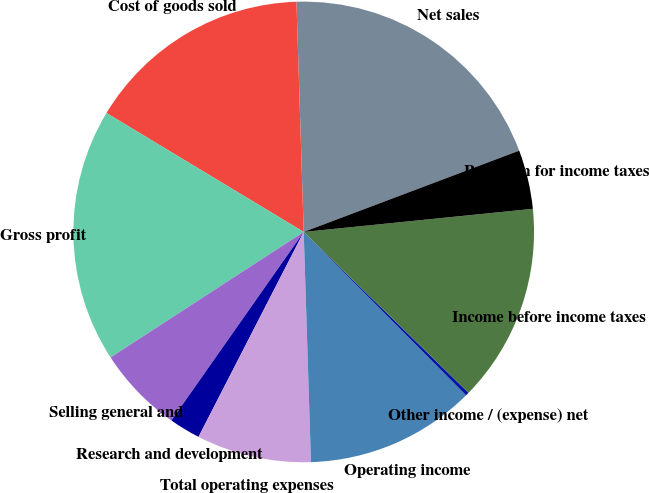Convert chart. <chart><loc_0><loc_0><loc_500><loc_500><pie_chart><fcel>Net sales<fcel>Cost of goods sold<fcel>Gross profit<fcel>Selling general and<fcel>Research and development<fcel>Total operating expenses<fcel>Operating income<fcel>Other income / (expense) net<fcel>Income before income taxes<fcel>Provision for income taxes<nl><fcel>19.76%<fcel>15.86%<fcel>17.81%<fcel>6.09%<fcel>2.19%<fcel>8.05%<fcel>11.95%<fcel>0.24%<fcel>13.91%<fcel>4.14%<nl></chart> 